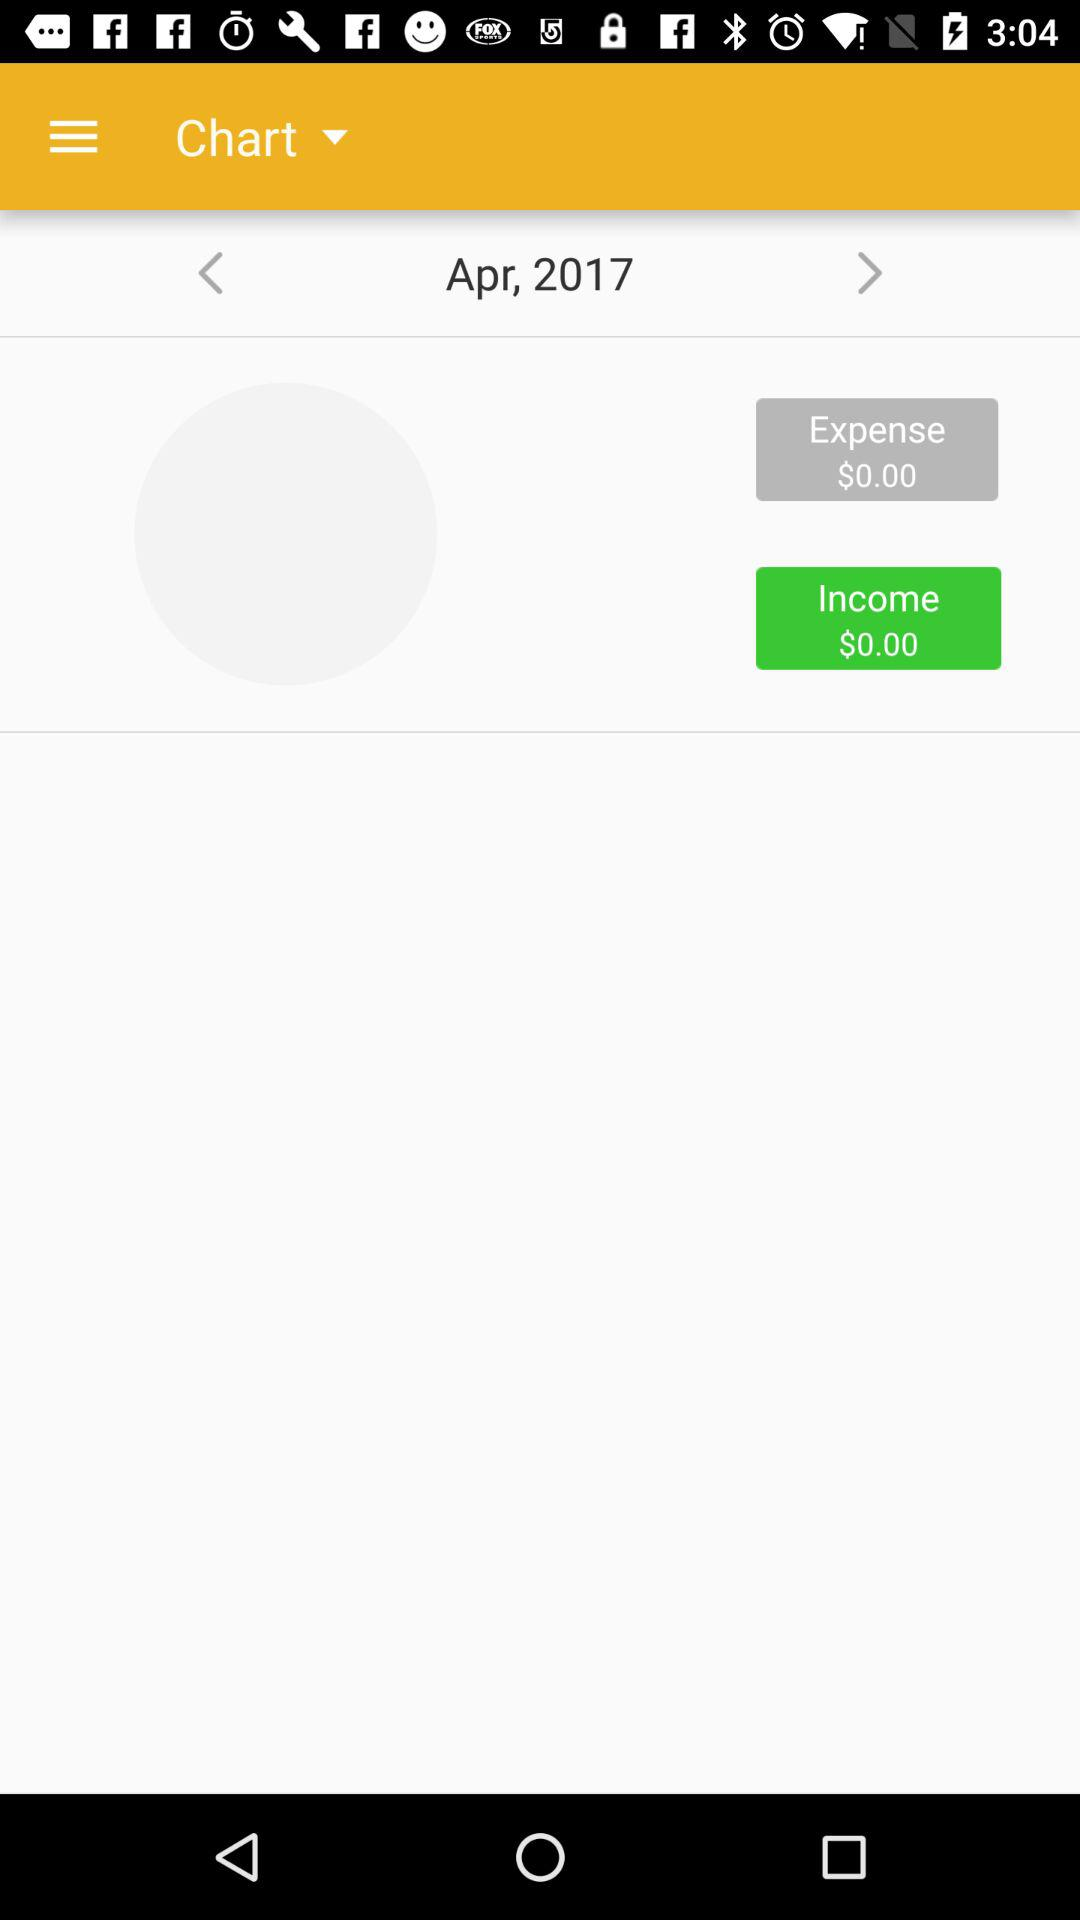On which date the amounts are recorded?
When the provided information is insufficient, respond with <no answer>. <no answer> 